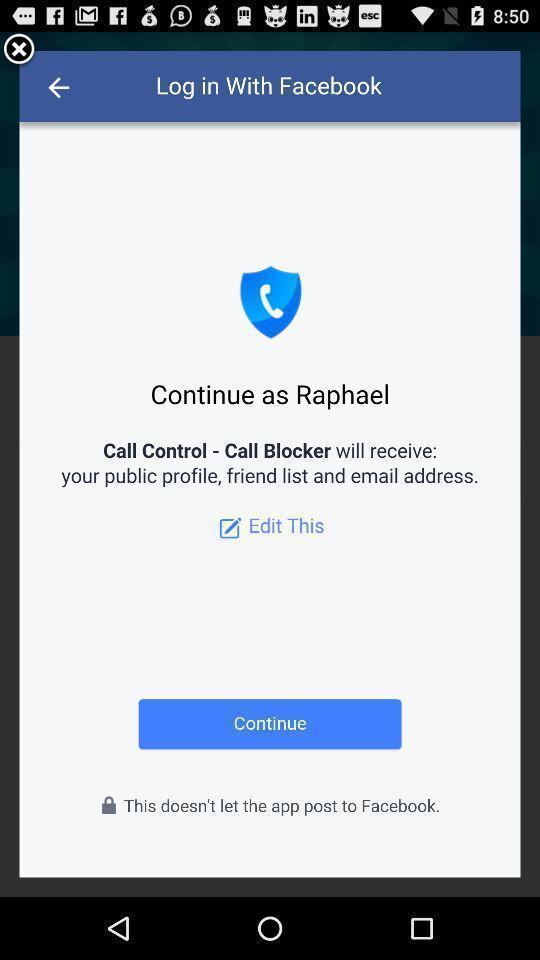Give me a summary of this screen capture. Pop-up showing a profile name to continue with the app. 